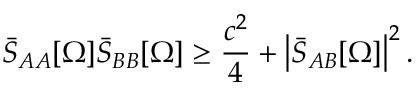<formula> <loc_0><loc_0><loc_500><loc_500>\bar { S } _ { A A } [ \Omega ] \bar { S } _ { B B } [ \Omega ] \geq \frac { c ^ { 2 } } { 4 } + \left | \bar { S } _ { A B } [ \Omega ] \right | ^ { 2 } .</formula> 